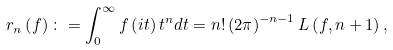Convert formula to latex. <formula><loc_0><loc_0><loc_500><loc_500>r _ { n } \left ( f \right ) \colon = \int _ { 0 } ^ { \infty } f \left ( i t \right ) t ^ { n } d t = n ! \left ( 2 \pi \right ) ^ { - n - 1 } L \left ( f , n + 1 \right ) ,</formula> 